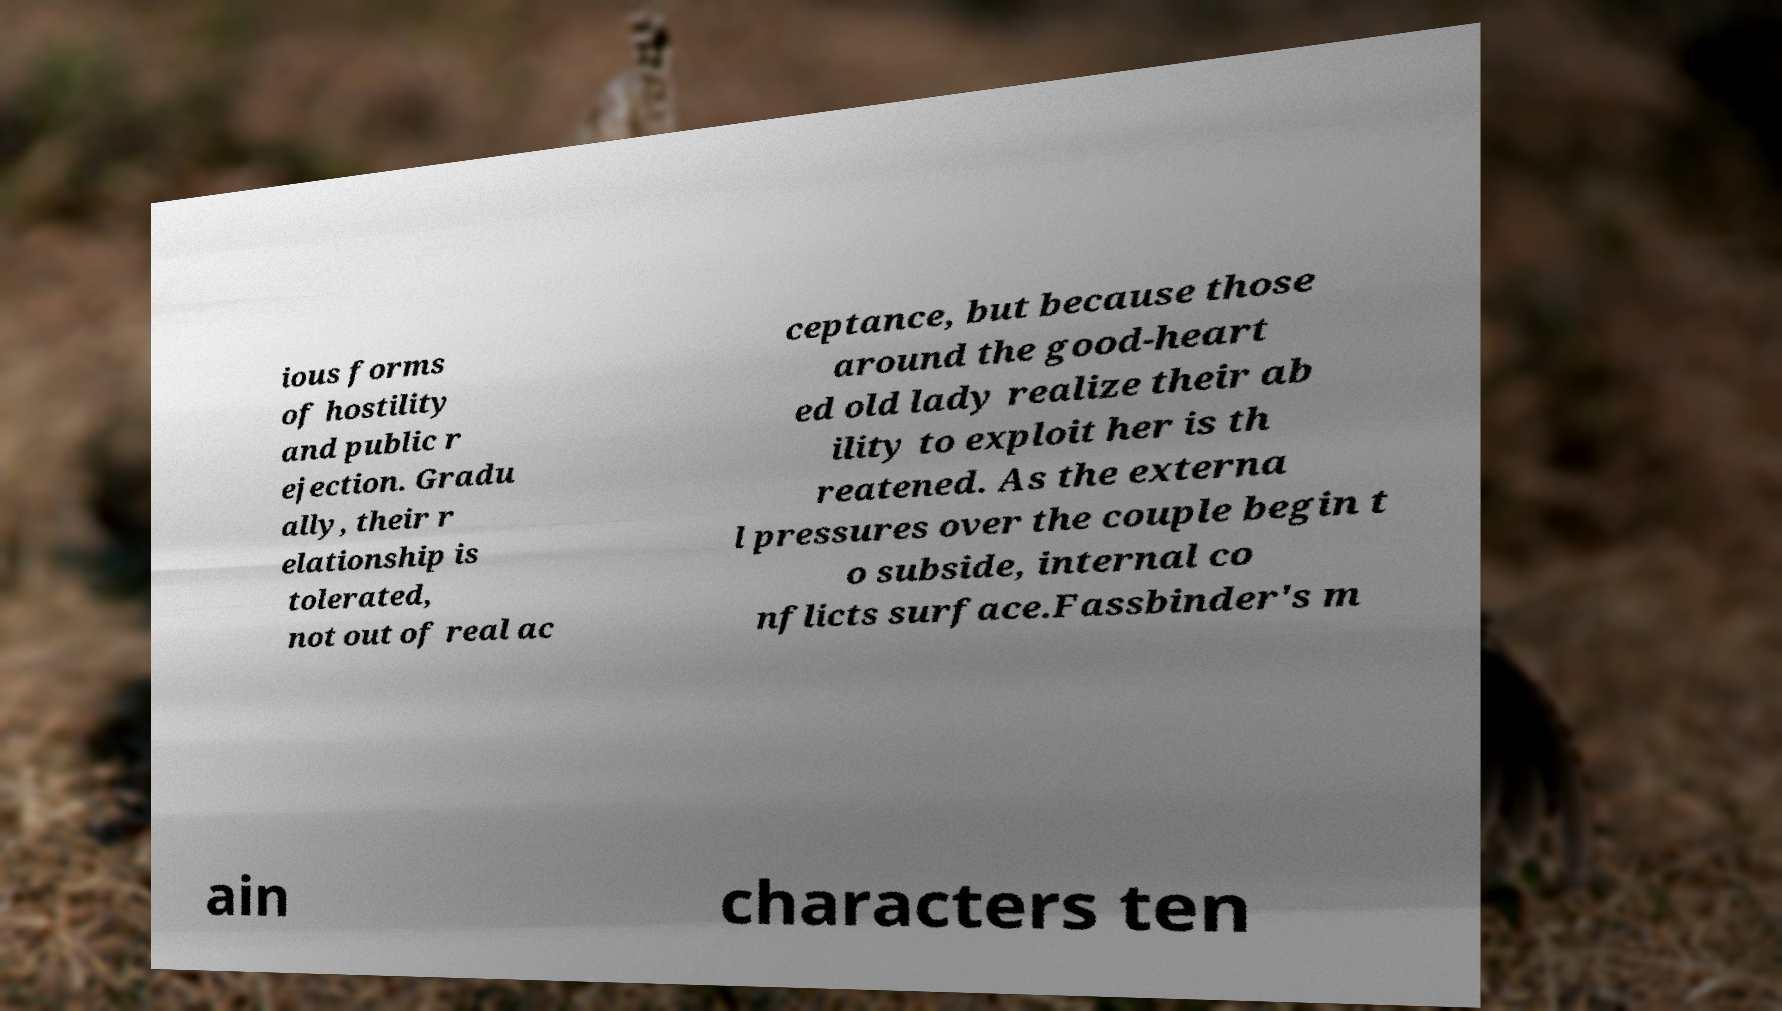What messages or text are displayed in this image? I need them in a readable, typed format. ious forms of hostility and public r ejection. Gradu ally, their r elationship is tolerated, not out of real ac ceptance, but because those around the good-heart ed old lady realize their ab ility to exploit her is th reatened. As the externa l pressures over the couple begin t o subside, internal co nflicts surface.Fassbinder's m ain characters ten 